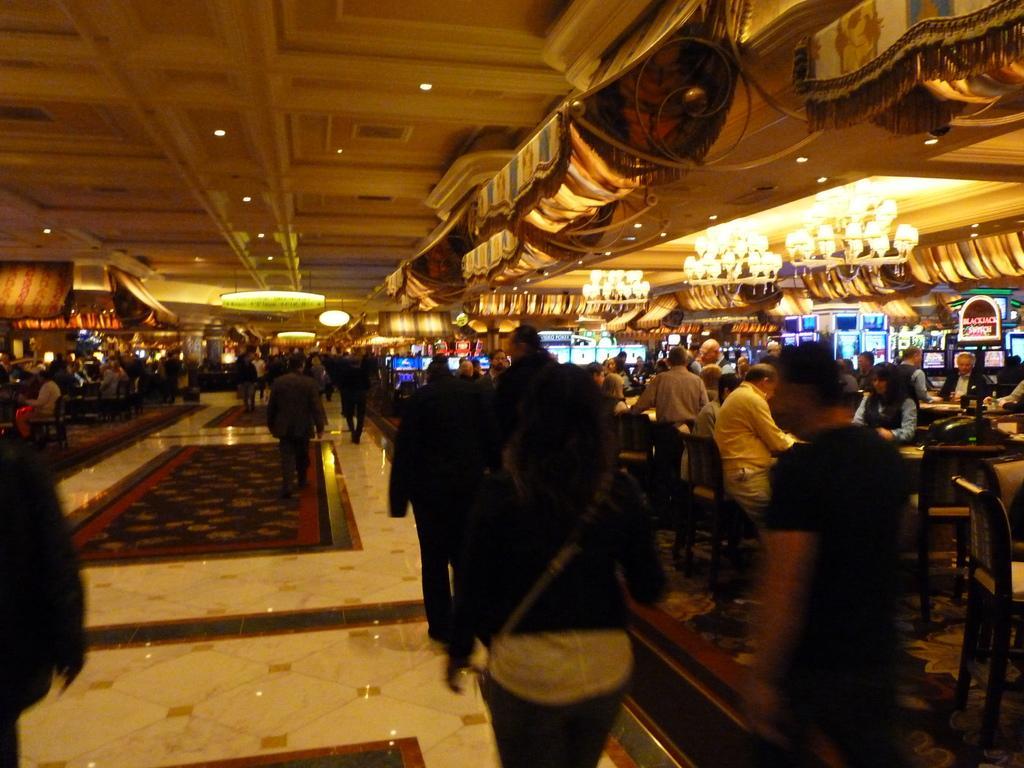Describe this image in one or two sentences. In this picture we can observe some people walking on the floor. The floor is in white and maroon color. There are men and women in this picture. We can observe some people sitting in the chair in front of their respective tables. In the background we can observe lights and chandeliers. 